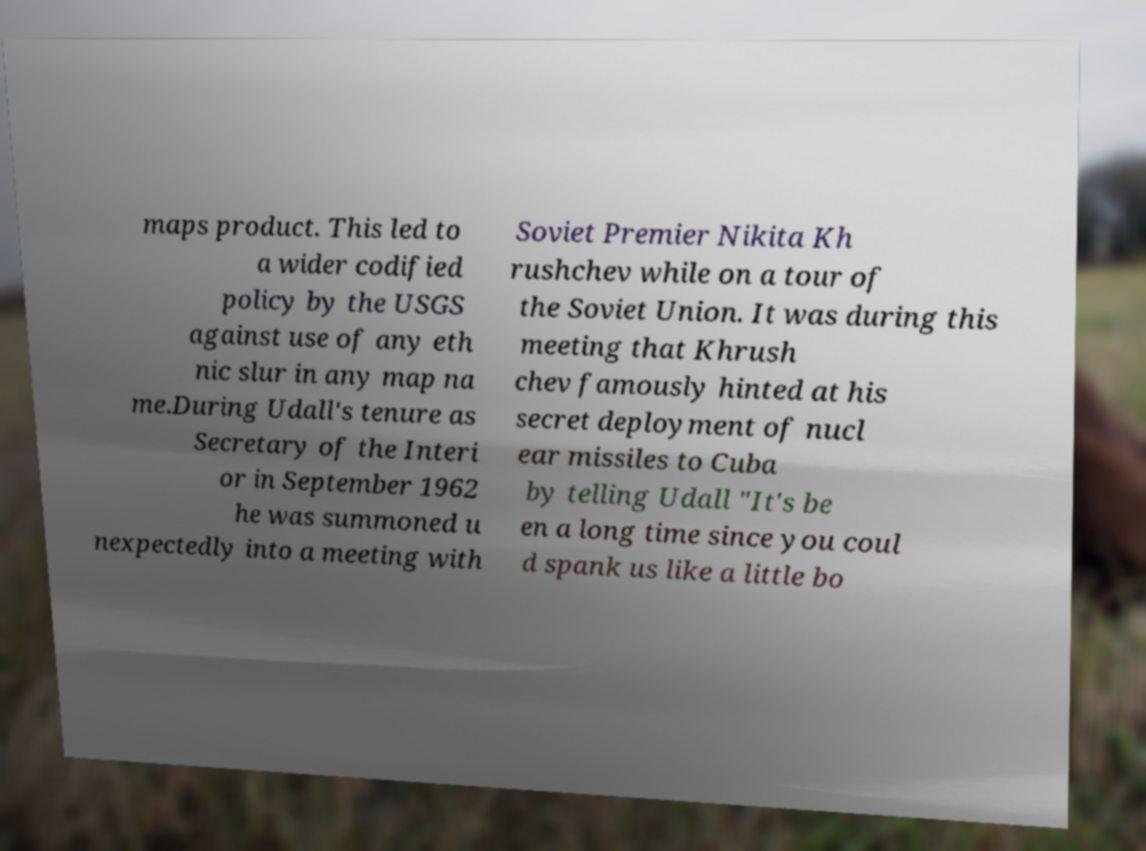Please identify and transcribe the text found in this image. maps product. This led to a wider codified policy by the USGS against use of any eth nic slur in any map na me.During Udall's tenure as Secretary of the Interi or in September 1962 he was summoned u nexpectedly into a meeting with Soviet Premier Nikita Kh rushchev while on a tour of the Soviet Union. It was during this meeting that Khrush chev famously hinted at his secret deployment of nucl ear missiles to Cuba by telling Udall "It's be en a long time since you coul d spank us like a little bo 